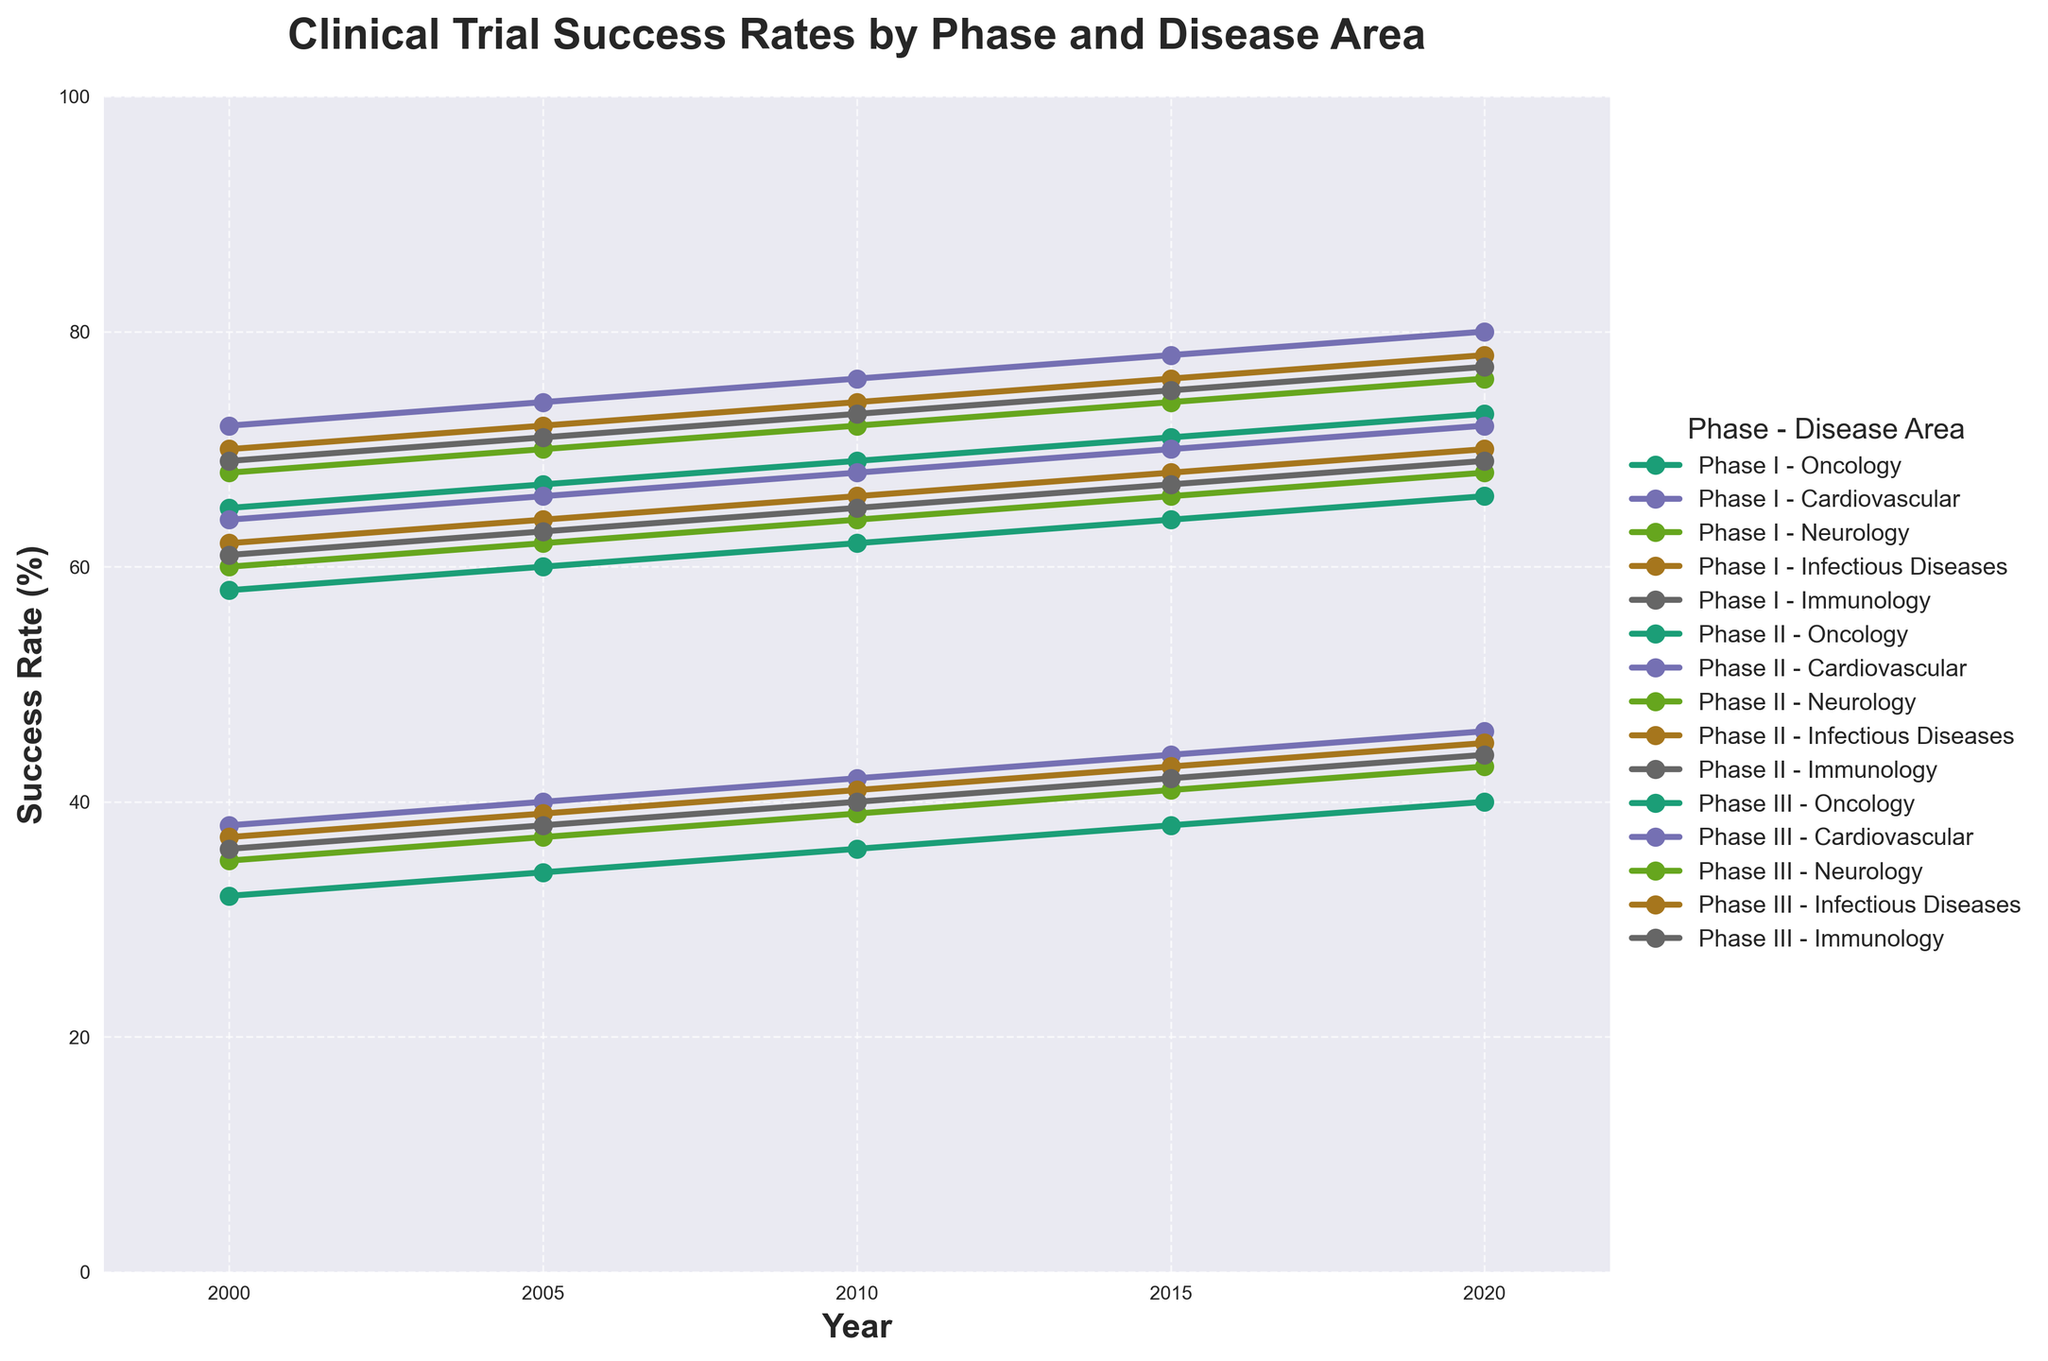Which disease area in Phase I shows the highest success rate in 2020? Refer to the Phase I data in the year 2020, compare the success rates for Oncology, Cardiovascular, Neurology, Infectious Diseases, and Immunology. The highest value is 80 for Cardiovascular.
Answer: Cardiovascular What is the overall trend of success rates in Phase II for Infectious Diseases from 2000 to 2020? Look at the data points for Infectious Diseases in Phase II over the years: 2000 (37), 2005 (39), 2010 (41), 2015 (43), 2020 (45). There is a clear increasing trend.
Answer: Increasing Which phase and disease area combination had the lowest success rate in 2000? Compare the success rates across all phases and disease areas in 2000. The lowest value is 32 for Oncology in Phase II.
Answer: Phase II - Oncology How did the success rates for Neurology in Phase I change between 2010 and 2015? Observe the values for Neurology in Phase I in 2010 (72) and 2015 (74). Subtract the 2010 value from the 2015 value: 74 - 72 = 2.
Answer: Increased by 2 What is the average success rate for Cardiovascular across all phases in 2020? Take the Cardiovascular success rates for all three phases in 2020: Phase I (80), Phase II (46), and Phase III (72). Sum these values and divide by 3. (80 + 46 + 72) / 3 = 66.
Answer: 66 Compare the success rates of Immunology in Phase III between 2000 and 2020. Which year had a higher rate and by how much? Look at the rates for Immunology in Phase III for 2000 (61) and 2020 (69). Find the difference: 69 - 61 = 8. 2020 has a higher rate.
Answer: 2020 by 8 During which period did the success rate for Oncology in Phase II increase the most? Compare the increases between the periods: 2000 to 2005 (34 - 32 = 2), 2005 to 2010 (36 - 34 = 2), 2010 to 2015 (38 - 36 = 2), 2015 to 2020 (40 - 38 = 2). All periods have the same increase of 2.
Answer: All periods equally Which disease area shows the largest increase in success rate in Phase II between 2000 and 2020? Analyze the change for each disease area in Phase II from 2000 to 2020: Oncology (40-32=8), Cardiovascular (46-38=8), Neurology (43-35=8), Infectious Diseases (45-37=8), Immunology (44-36=8). All increases are equal.
Answer: All disease areas equally Which disease area in Phase III had the smallest success rate improvement from 2000 to 2020? Evaluate the improvements for each disease area in Phase III: Oncology (66-58=8), Cardiovascular (72-64=8), Neurology (68-60=8), Infectious Diseases (70-62=8), Immunology (69-61=8). All improvements are equal.
Answer: All disease areas equally Is there a correlation between the year and the success rates in Phase I for Immunology? Observe the trend in Immunology success rates in Phase I from 2000 (69), 2005 (71), 2010 (73), 2015 (75), 2020 (77). The rates increase consistently over the years, suggesting a positive correlation.
Answer: Positive correlation 